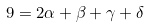<formula> <loc_0><loc_0><loc_500><loc_500>9 = 2 \alpha + \beta + \gamma + \delta</formula> 